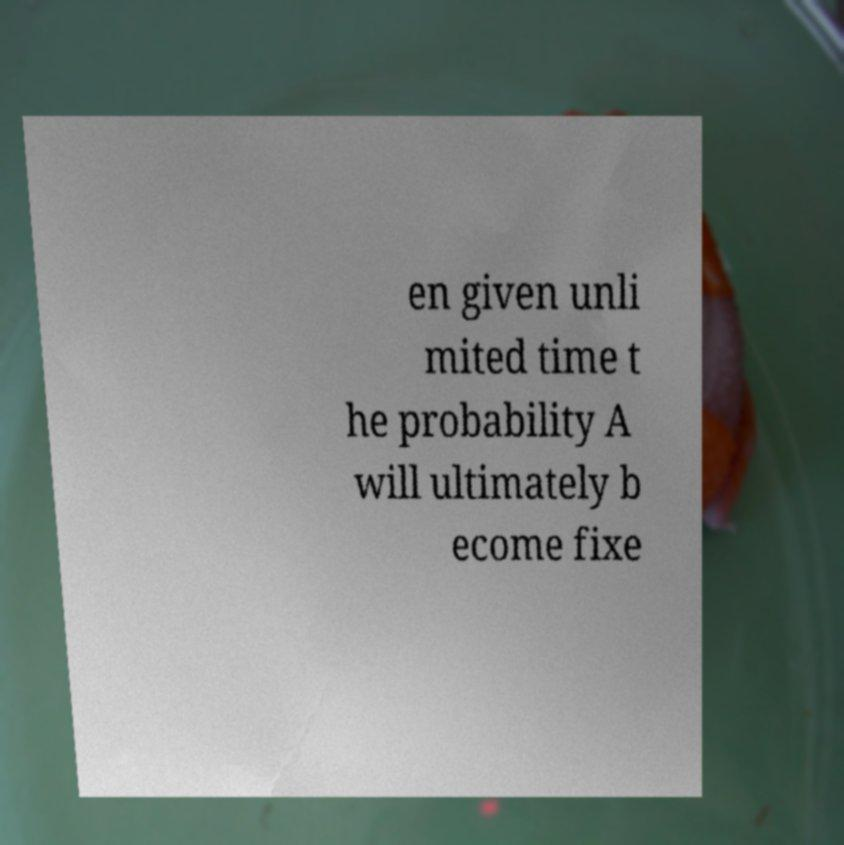There's text embedded in this image that I need extracted. Can you transcribe it verbatim? en given unli mited time t he probability A will ultimately b ecome fixe 